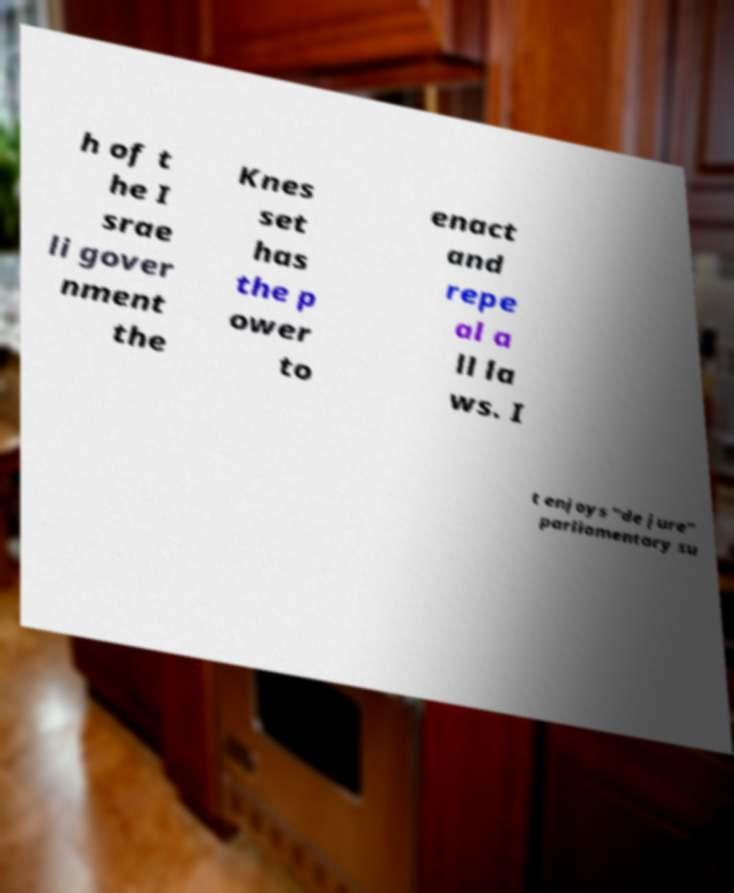Could you assist in decoding the text presented in this image and type it out clearly? h of t he I srae li gover nment the Knes set has the p ower to enact and repe al a ll la ws. I t enjoys "de jure" parliamentary su 